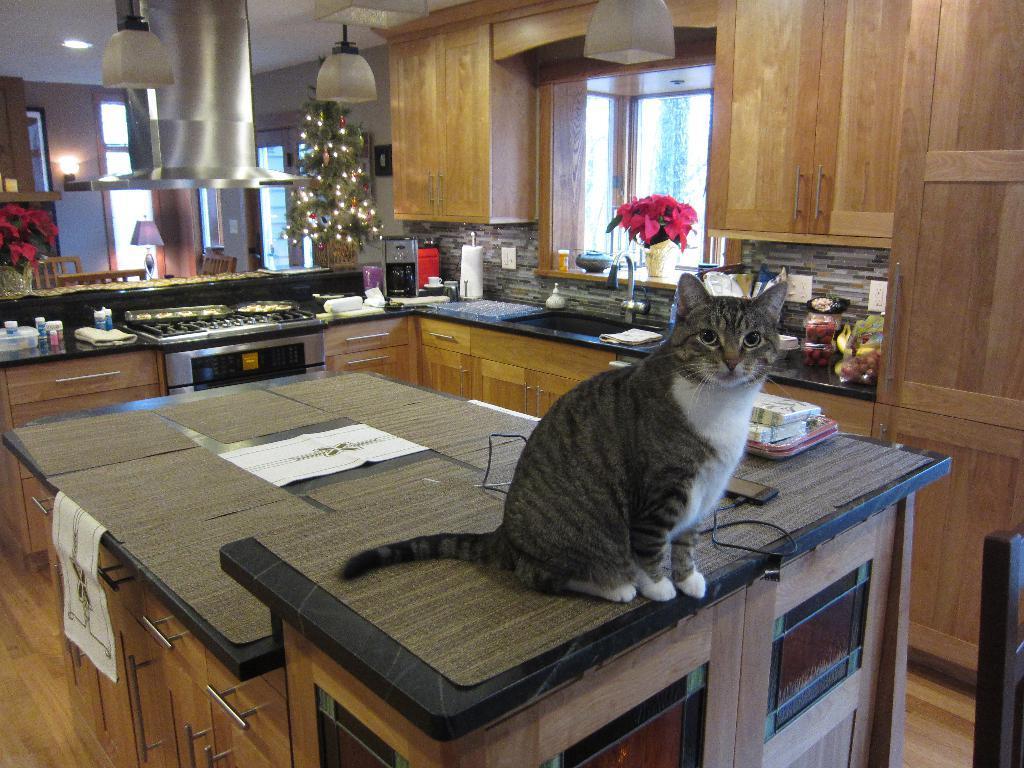How would you summarize this image in a sentence or two? This picture is clicked in room. In front of picture, we see a cat which is sitting on a table. Behind that, we see a counter top on which flower vase, bottle and plastic box are placed. We even see a gas stove. Behind that, we see Christmas tree. Beside that, we see cupboard and window. 